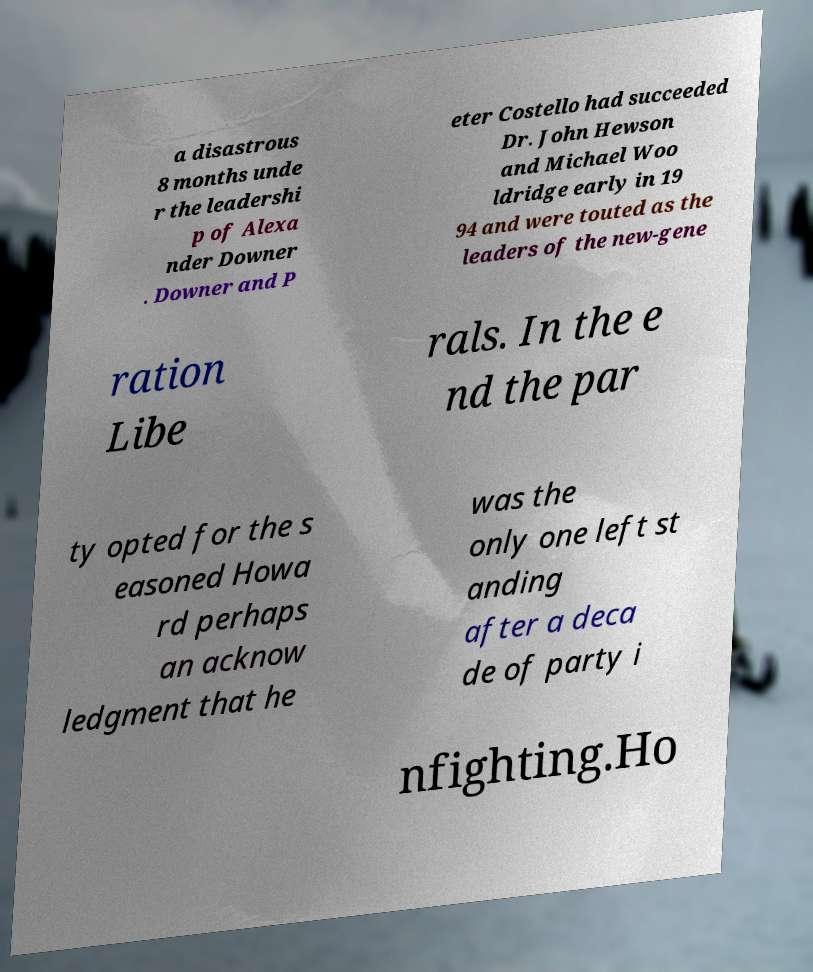Could you extract and type out the text from this image? a disastrous 8 months unde r the leadershi p of Alexa nder Downer . Downer and P eter Costello had succeeded Dr. John Hewson and Michael Woo ldridge early in 19 94 and were touted as the leaders of the new-gene ration Libe rals. In the e nd the par ty opted for the s easoned Howa rd perhaps an acknow ledgment that he was the only one left st anding after a deca de of party i nfighting.Ho 